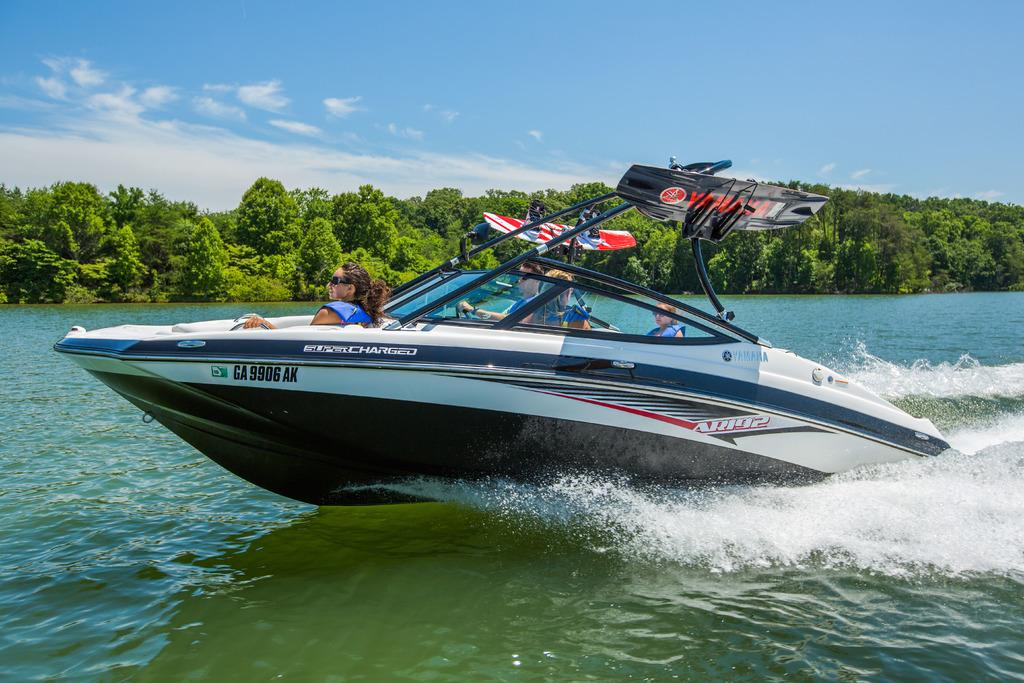How many people are in the image? There are four persons in the image. Where are the persons located in the image? The persons are on a boat. What can be seen below the boat in the image? There is water visible in the image. What is visible in the background of the image? There are trees and the sky visible in the background of the image. What type of sponge is being used by the actor in the image? There is no actor or sponge present in the image. How is the glue being applied by the persons in the image? There is no glue present in the image; the persons are on a boat. 